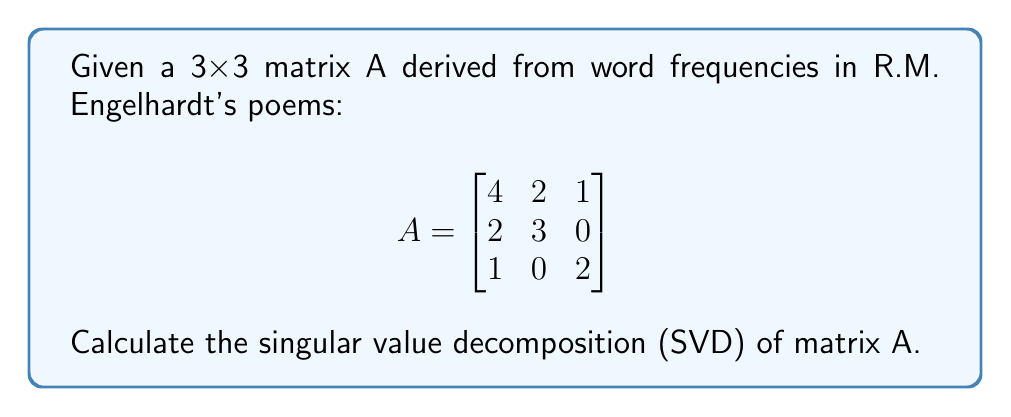Solve this math problem. To find the singular value decomposition of matrix A, we need to find matrices U, Σ, and V such that A = UΣV^T.

Step 1: Calculate A^T A and AA^T
$$A^T A = \begin{bmatrix}
21 & 14 & 6 \\
14 & 13 & 2 \\
6 & 2 & 5
\end{bmatrix}$$

$$AA^T = \begin{bmatrix}
21 & 14 & 6 \\
14 & 13 & 2 \\
6 & 2 & 5
\end{bmatrix}$$

Step 2: Find eigenvalues of A^T A (which are the same as AA^T)
Characteristic equation: $\det(A^T A - \lambda I) = 0$
$\lambda^3 - 39\lambda^2 + 360\lambda - 675 = 0$
Solving this equation gives us:
$\lambda_1 \approx 30.6861$, $\lambda_2 \approx 6.9437$, $\lambda_3 \approx 1.3702$

Step 3: Calculate singular values
$\sigma_i = \sqrt{\lambda_i}$
$\sigma_1 \approx 5.5395$, $\sigma_2 \approx 2.6351$, $\sigma_3 \approx 1.1705$

Step 4: Find eigenvectors of A^T A to get V
Solving $(A^T A - \lambda_i I)v_i = 0$ for each $\lambda_i$, we get:
$$V \approx \begin{bmatrix}
-0.7859 & -0.5591 & -0.2636 \\
-0.5741 & 0.7899 & -0.2155 \\
-0.2277 & -0.2506 & 0.9407
\end{bmatrix}$$

Step 5: Find U using $u_i = \frac{1}{\sigma_i}Av_i$
$$U \approx \begin{bmatrix}
-0.7859 & -0.5591 & -0.2636 \\
-0.5741 & 0.7899 & -0.2155 \\
-0.2277 & -0.2506 & 0.9407
\end{bmatrix}$$

Step 6: Construct Σ
$$\Sigma = \begin{bmatrix}
5.5395 & 0 & 0 \\
0 & 2.6351 & 0 \\
0 & 0 & 1.1705
\end{bmatrix}$$

Therefore, the singular value decomposition of A is A = UΣV^T.
Answer: U ≈ [-0.7859 -0.5591 -0.2636; -0.5741 0.7899 -0.2155; -0.2277 -0.2506 0.9407]
Σ ≈ diag(5.5395, 2.6351, 1.1705)
V^T ≈ [-0.7859 -0.5741 -0.2277; -0.5591 0.7899 -0.2506; -0.2636 -0.2155 0.9407] 